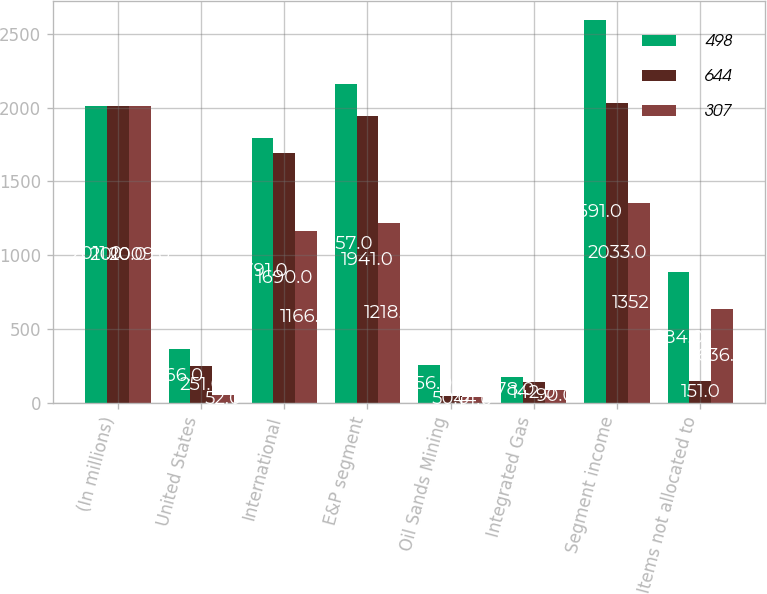Convert chart. <chart><loc_0><loc_0><loc_500><loc_500><stacked_bar_chart><ecel><fcel>(In millions)<fcel>United States<fcel>International<fcel>E&P segment<fcel>Oil Sands Mining<fcel>Integrated Gas<fcel>Segment income<fcel>Items not allocated to<nl><fcel>498<fcel>2011<fcel>366<fcel>1791<fcel>2157<fcel>256<fcel>178<fcel>2591<fcel>884<nl><fcel>644<fcel>2010<fcel>251<fcel>1690<fcel>1941<fcel>50<fcel>142<fcel>2033<fcel>151<nl><fcel>307<fcel>2009<fcel>52<fcel>1166<fcel>1218<fcel>44<fcel>90<fcel>1352<fcel>636<nl></chart> 